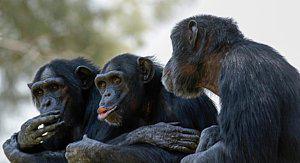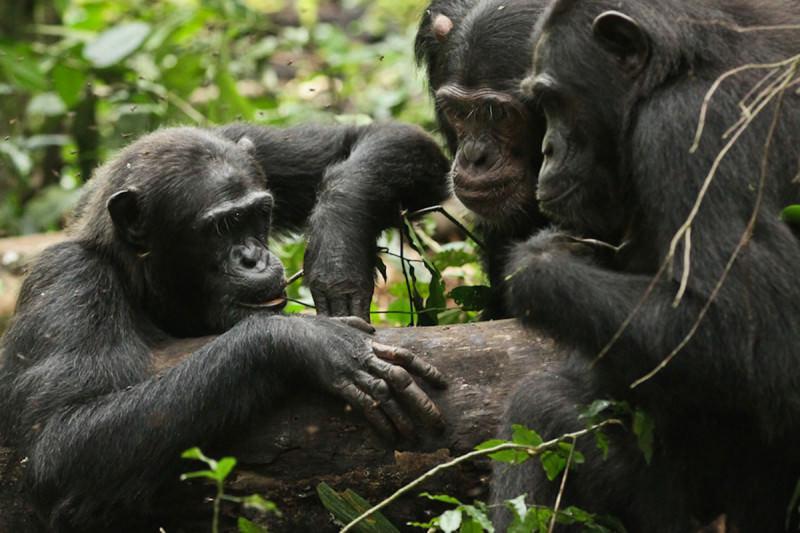The first image is the image on the left, the second image is the image on the right. For the images shown, is this caption "Six chimps can be seen" true? Answer yes or no. Yes. The first image is the image on the left, the second image is the image on the right. For the images shown, is this caption "One image includes an adult chimp lying on its side face-to-face with a baby chimp and holding the baby chimp's leg." true? Answer yes or no. No. The first image is the image on the left, the second image is the image on the right. Evaluate the accuracy of this statement regarding the images: "There is a chimpanzee showing something in his hand to two other chimpanzees in the right image.". Is it true? Answer yes or no. No. The first image is the image on the left, the second image is the image on the right. Examine the images to the left and right. Is the description "The lefthand image includes an adult chimp and a small juvenile chimp." accurate? Answer yes or no. No. 